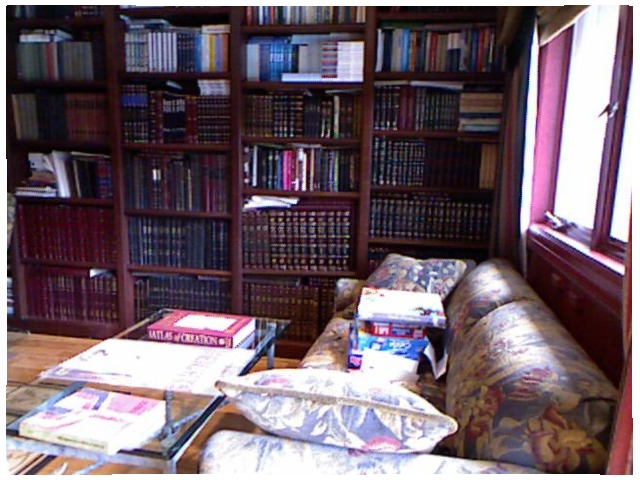<image>
Is there a book on the shelf? Yes. Looking at the image, I can see the book is positioned on top of the shelf, with the shelf providing support. Is the book above the table? No. The book is not positioned above the table. The vertical arrangement shows a different relationship. Is there a pillow next to the book? Yes. The pillow is positioned adjacent to the book, located nearby in the same general area. 